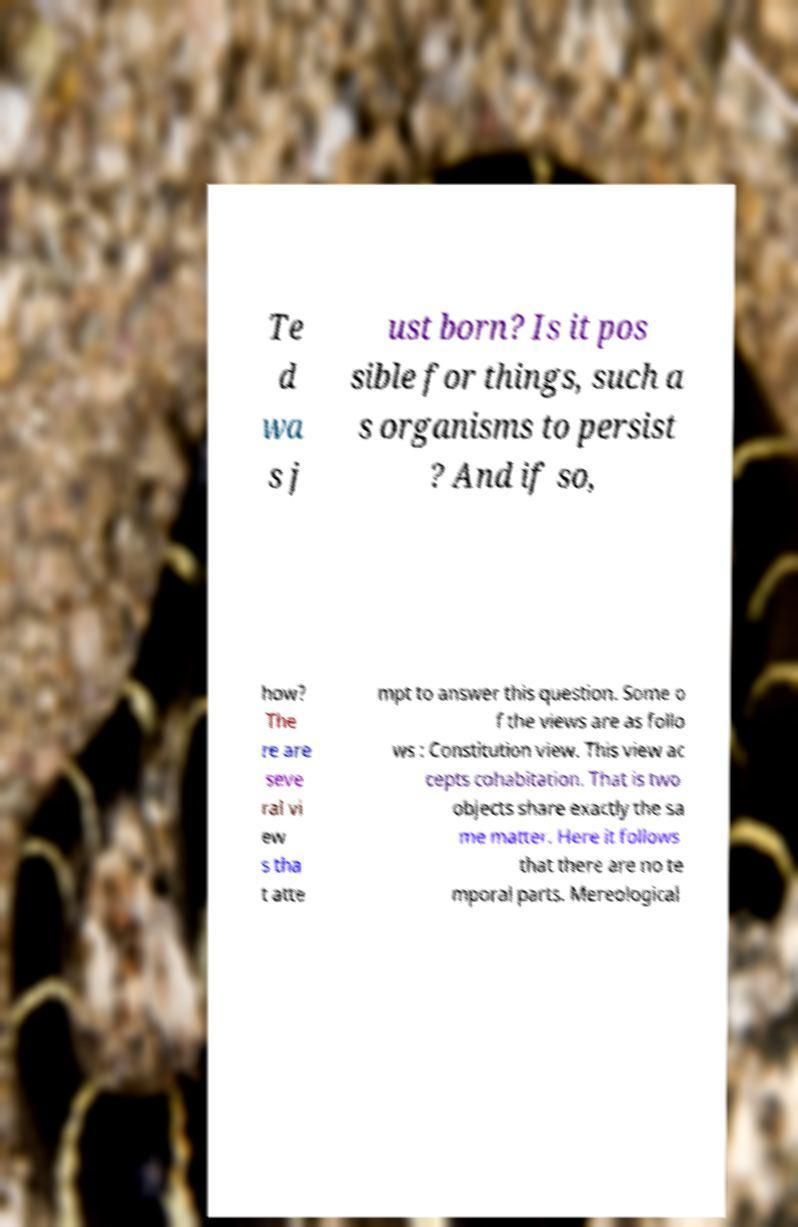Could you assist in decoding the text presented in this image and type it out clearly? Te d wa s j ust born? Is it pos sible for things, such a s organisms to persist ? And if so, how? The re are seve ral vi ew s tha t atte mpt to answer this question. Some o f the views are as follo ws : Constitution view. This view ac cepts cohabitation. That is two objects share exactly the sa me matter. Here it follows that there are no te mporal parts. Mereological 